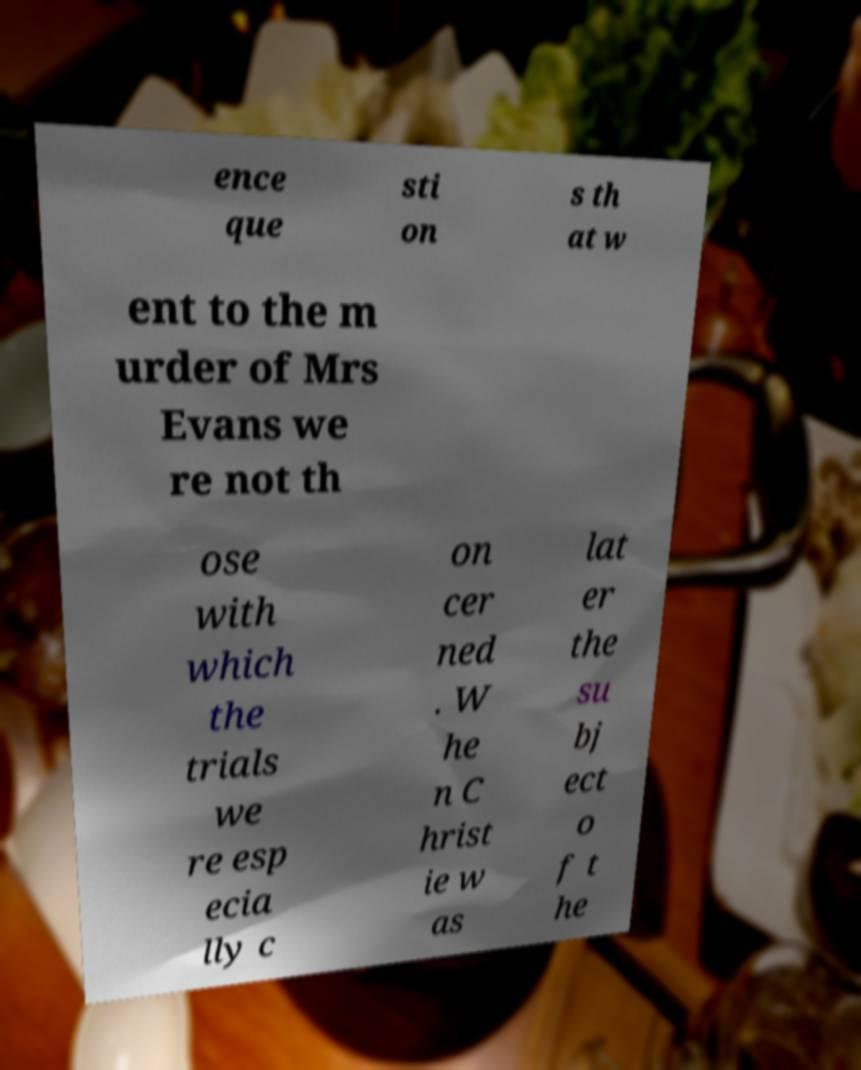What messages or text are displayed in this image? I need them in a readable, typed format. ence que sti on s th at w ent to the m urder of Mrs Evans we re not th ose with which the trials we re esp ecia lly c on cer ned . W he n C hrist ie w as lat er the su bj ect o f t he 